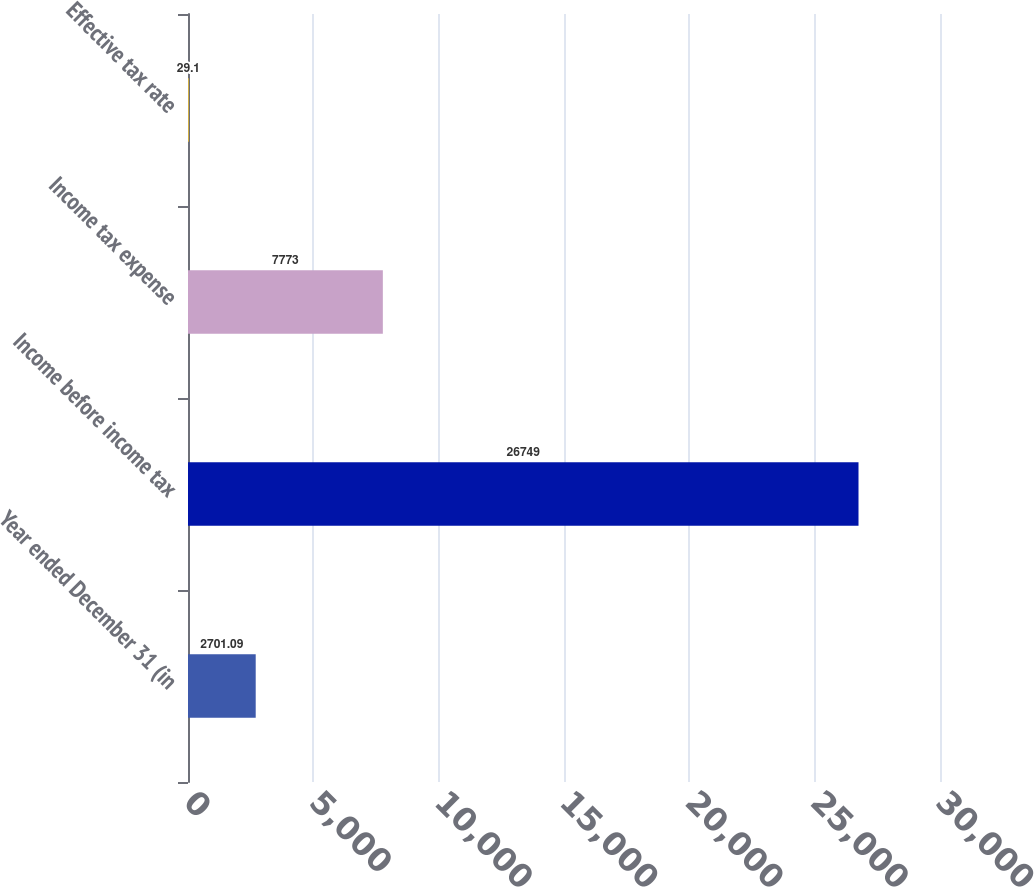<chart> <loc_0><loc_0><loc_500><loc_500><bar_chart><fcel>Year ended December 31 (in<fcel>Income before income tax<fcel>Income tax expense<fcel>Effective tax rate<nl><fcel>2701.09<fcel>26749<fcel>7773<fcel>29.1<nl></chart> 